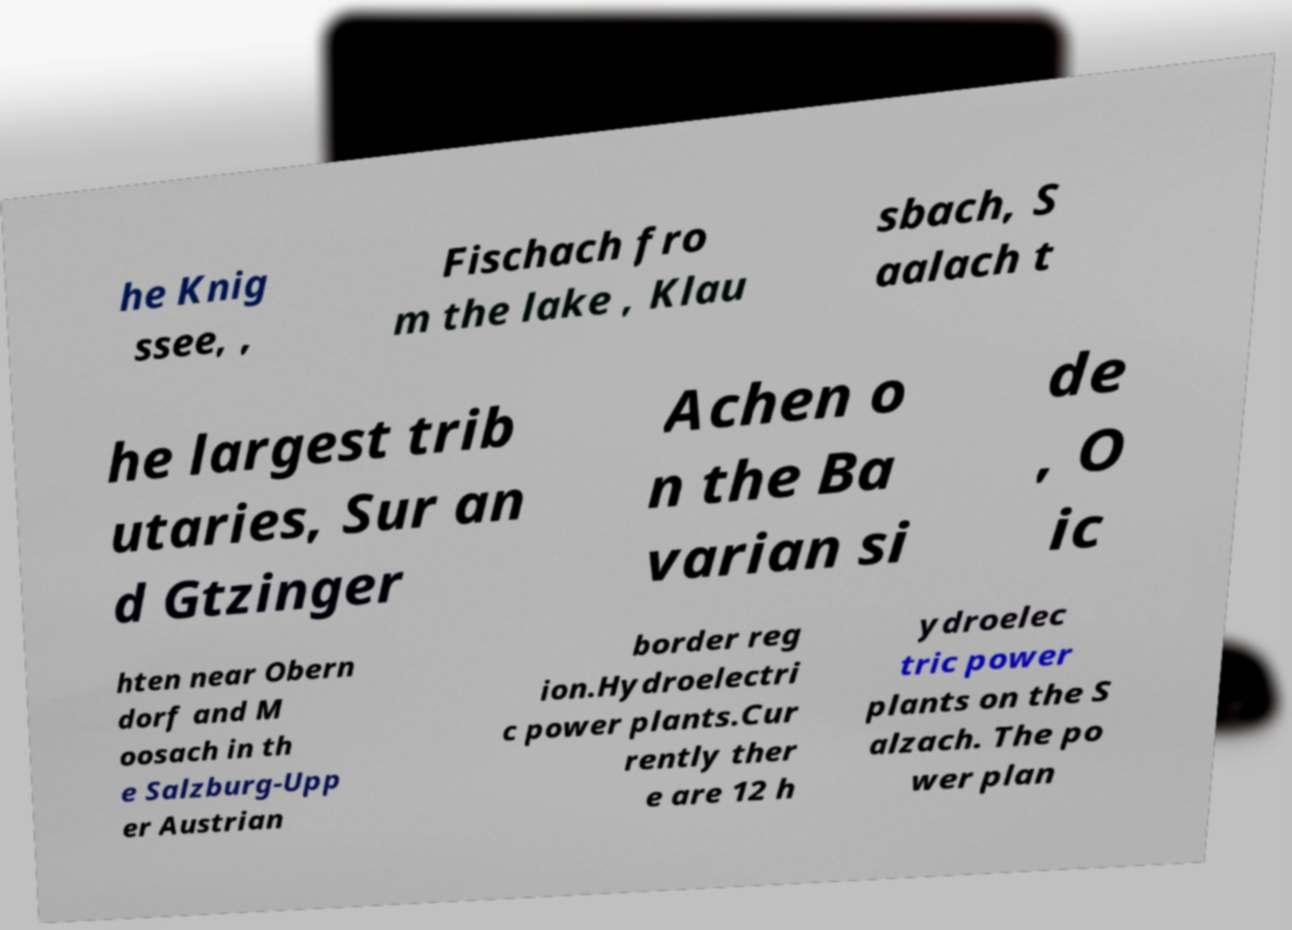I need the written content from this picture converted into text. Can you do that? he Knig ssee, , Fischach fro m the lake , Klau sbach, S aalach t he largest trib utaries, Sur an d Gtzinger Achen o n the Ba varian si de , O ic hten near Obern dorf and M oosach in th e Salzburg-Upp er Austrian border reg ion.Hydroelectri c power plants.Cur rently ther e are 12 h ydroelec tric power plants on the S alzach. The po wer plan 